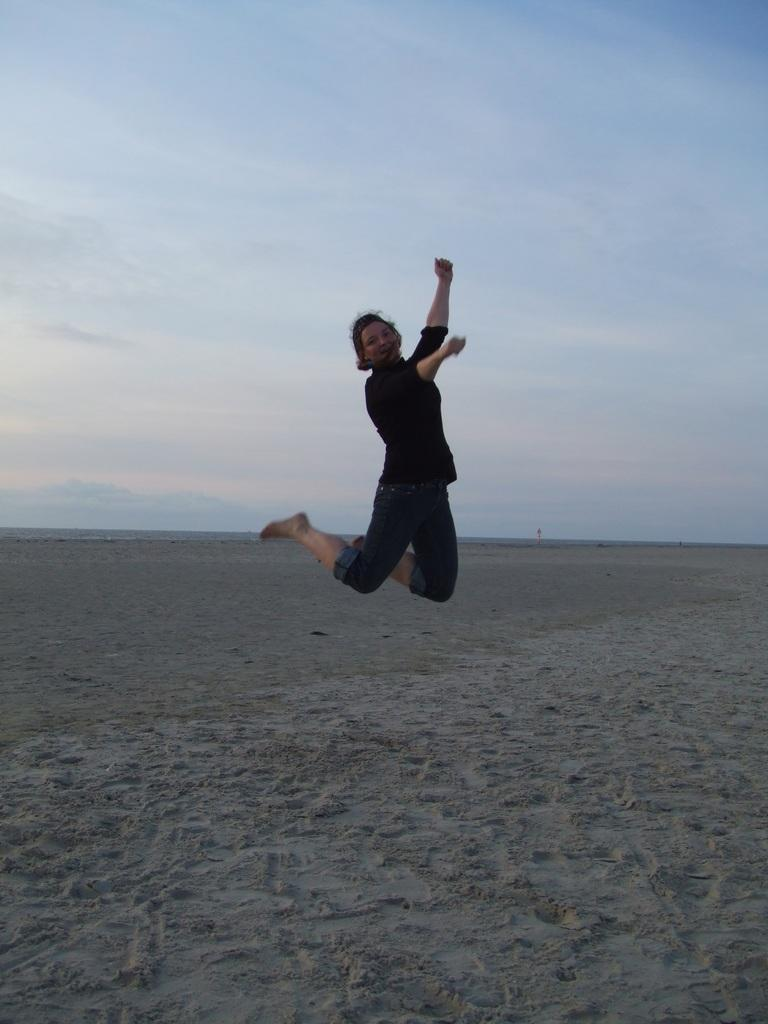What is the person in the image doing? There is a person jumping in the image. What type of surface is the person jumping on? There is sand visible in the image, which suggests the person is jumping on sand. What can be seen in the background of the image? The sky is visible in the image. What is the profit margin of the liquid in the image? There is no liquid present in the image, so it is not possible to determine the profit margin. 